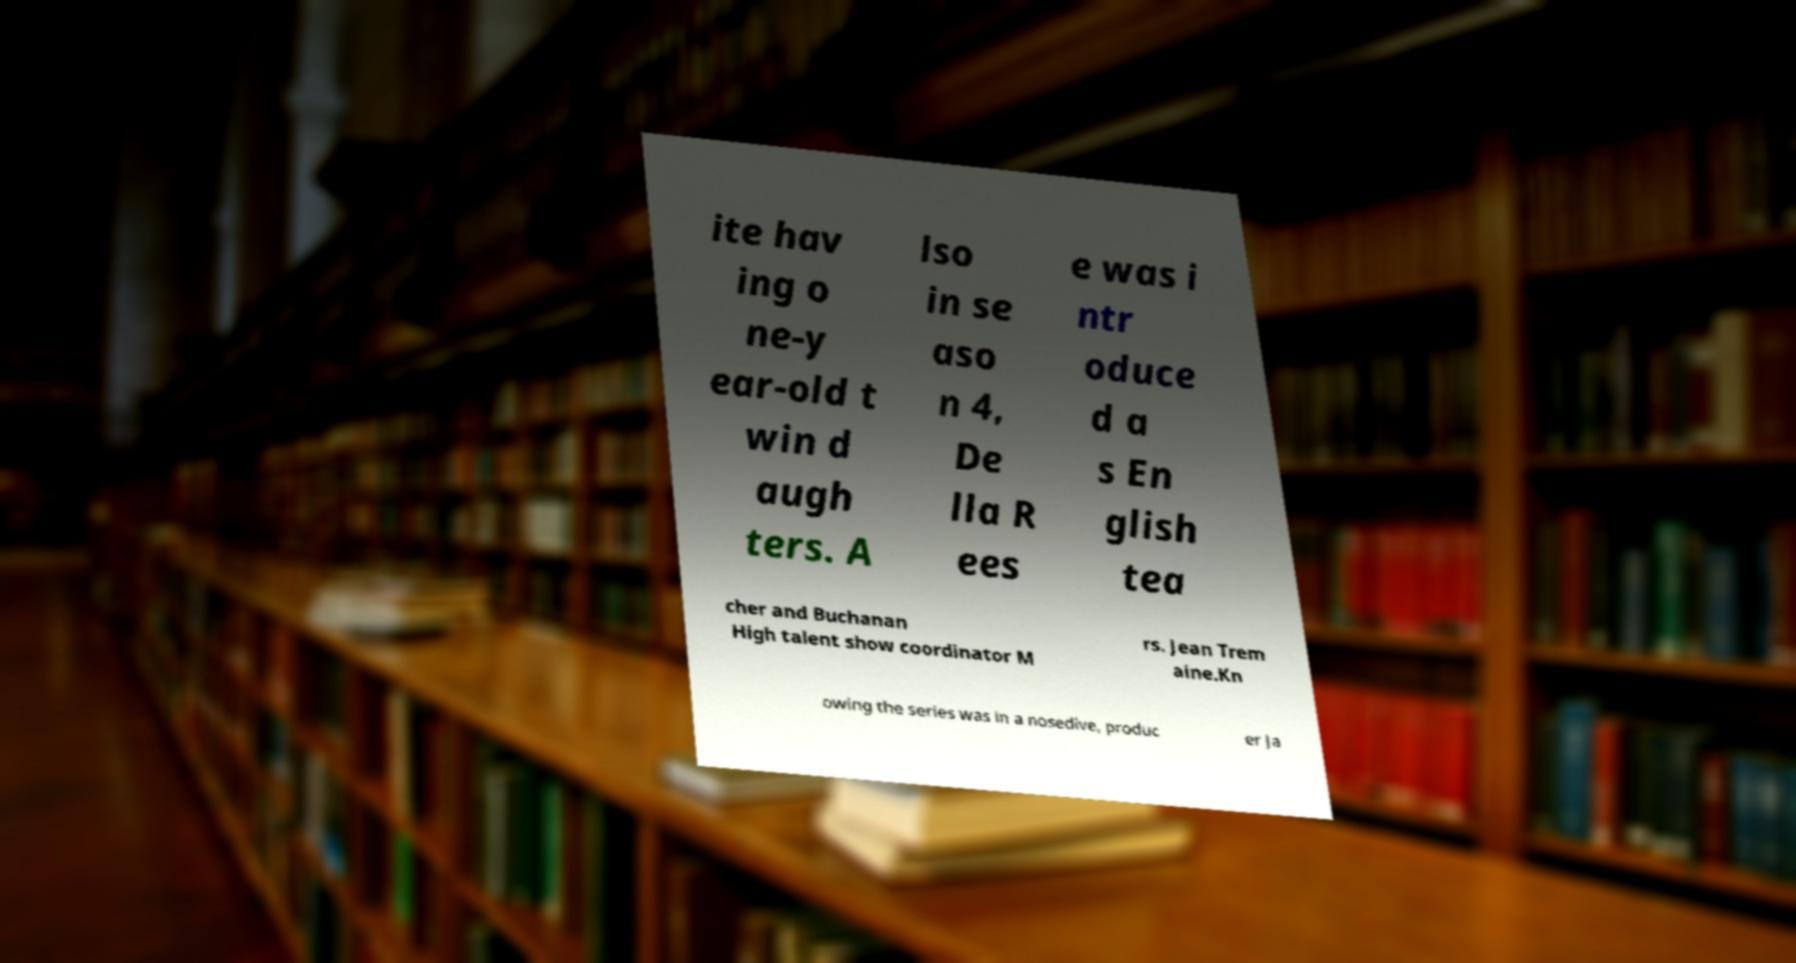Can you read and provide the text displayed in the image?This photo seems to have some interesting text. Can you extract and type it out for me? ite hav ing o ne-y ear-old t win d augh ters. A lso in se aso n 4, De lla R ees e was i ntr oduce d a s En glish tea cher and Buchanan High talent show coordinator M rs. Jean Trem aine.Kn owing the series was in a nosedive, produc er Ja 